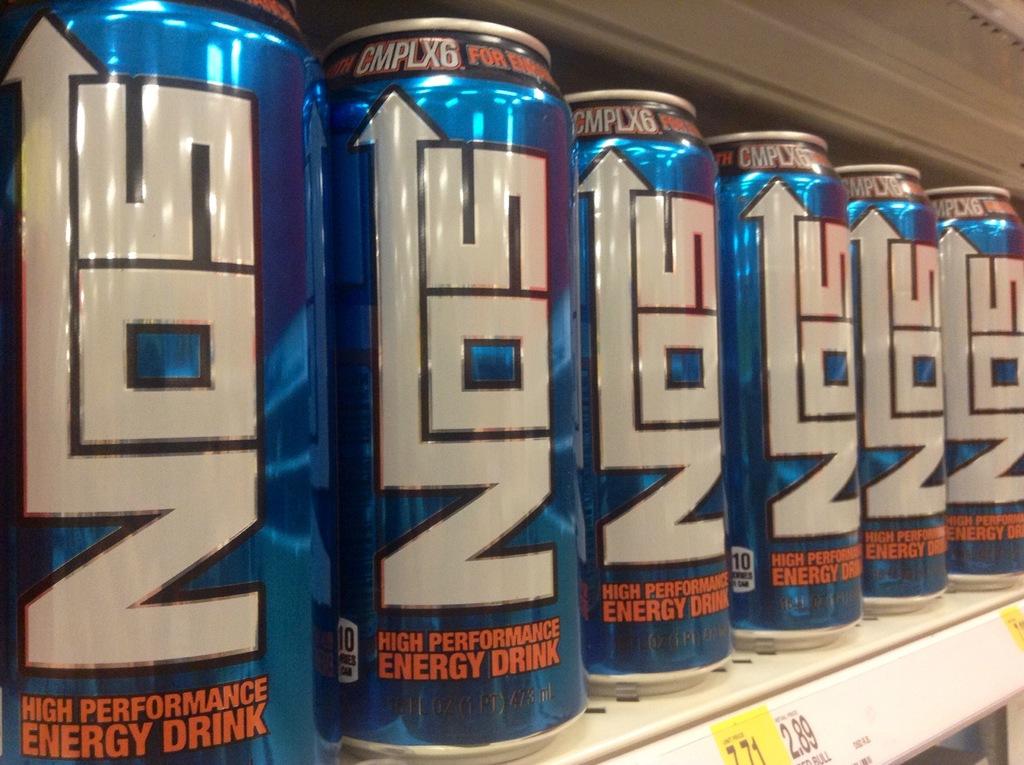What brand of energy drink are these?
Your answer should be very brief. Nos. What kind of drink is a nos?
Make the answer very short. High performance energy drink. 